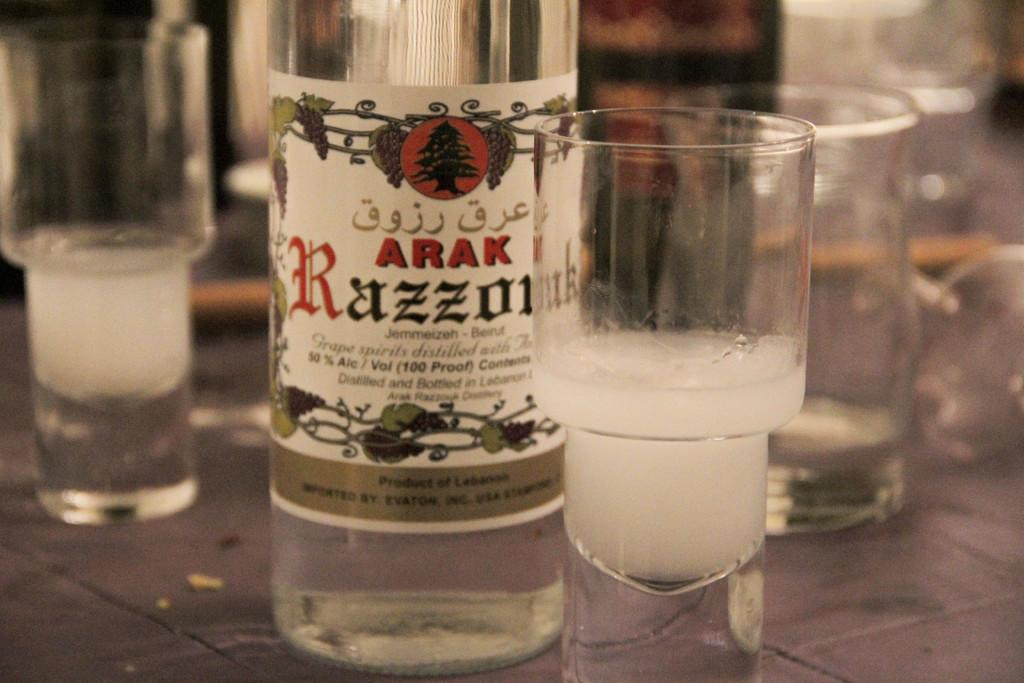Provide a one-sentence caption for the provided image. A bottle of Arak 50% alcohol and some shot glasses beside it. 